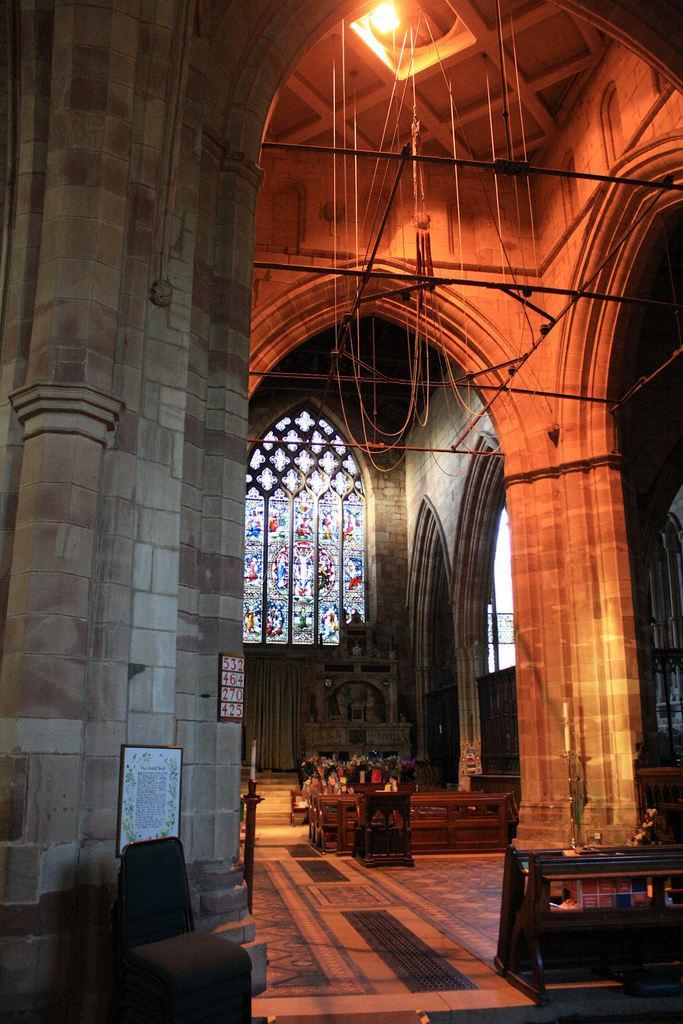Describe this image in one or two sentences. In this image I can see the inner part of the building and I can also see few wooden objects, few lights and I can also see a window. 